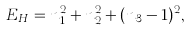<formula> <loc_0><loc_0><loc_500><loc_500>E _ { H } = n _ { 1 } ^ { 2 } + n _ { 2 } ^ { 2 } + ( n _ { 3 } - 1 ) ^ { 2 } ,</formula> 